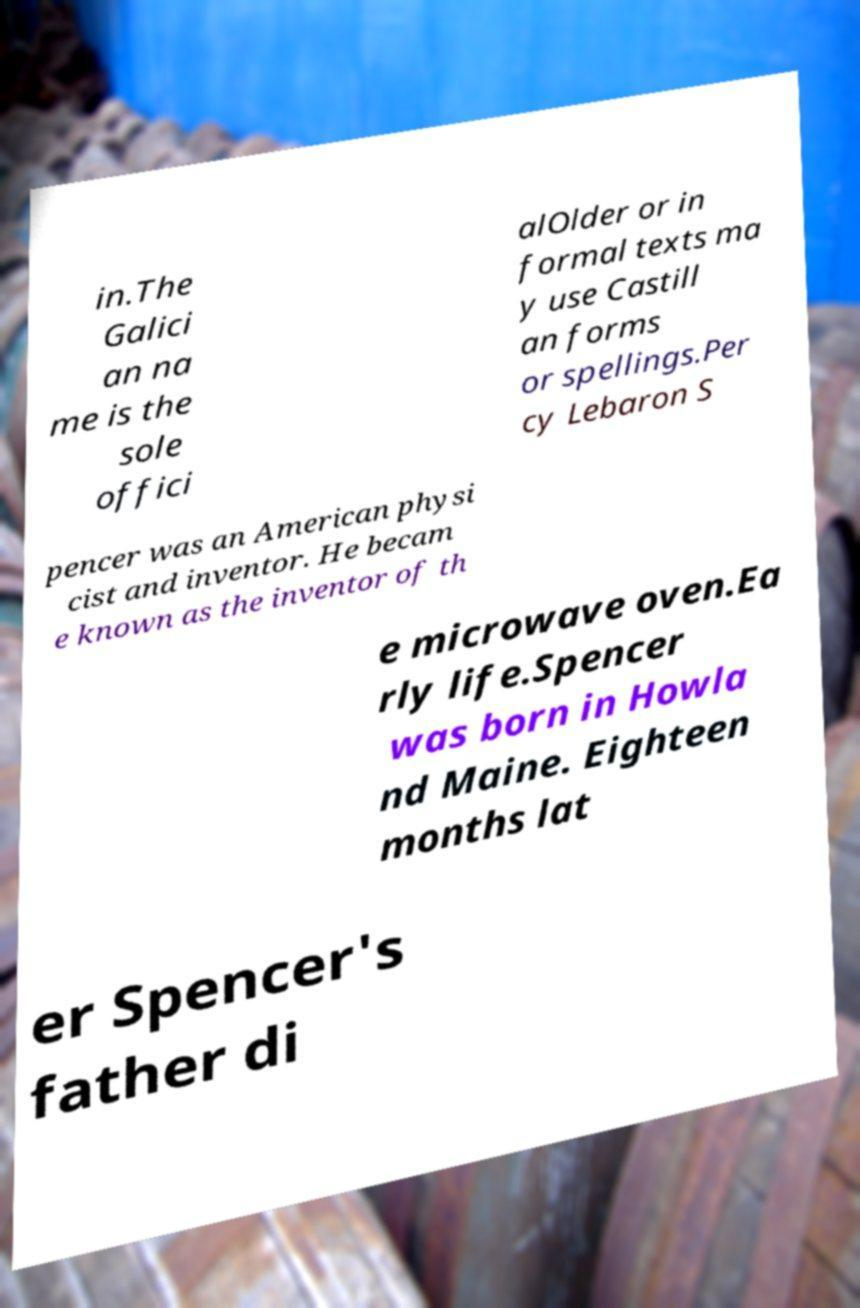Can you read and provide the text displayed in the image?This photo seems to have some interesting text. Can you extract and type it out for me? in.The Galici an na me is the sole offici alOlder or in formal texts ma y use Castill an forms or spellings.Per cy Lebaron S pencer was an American physi cist and inventor. He becam e known as the inventor of th e microwave oven.Ea rly life.Spencer was born in Howla nd Maine. Eighteen months lat er Spencer's father di 